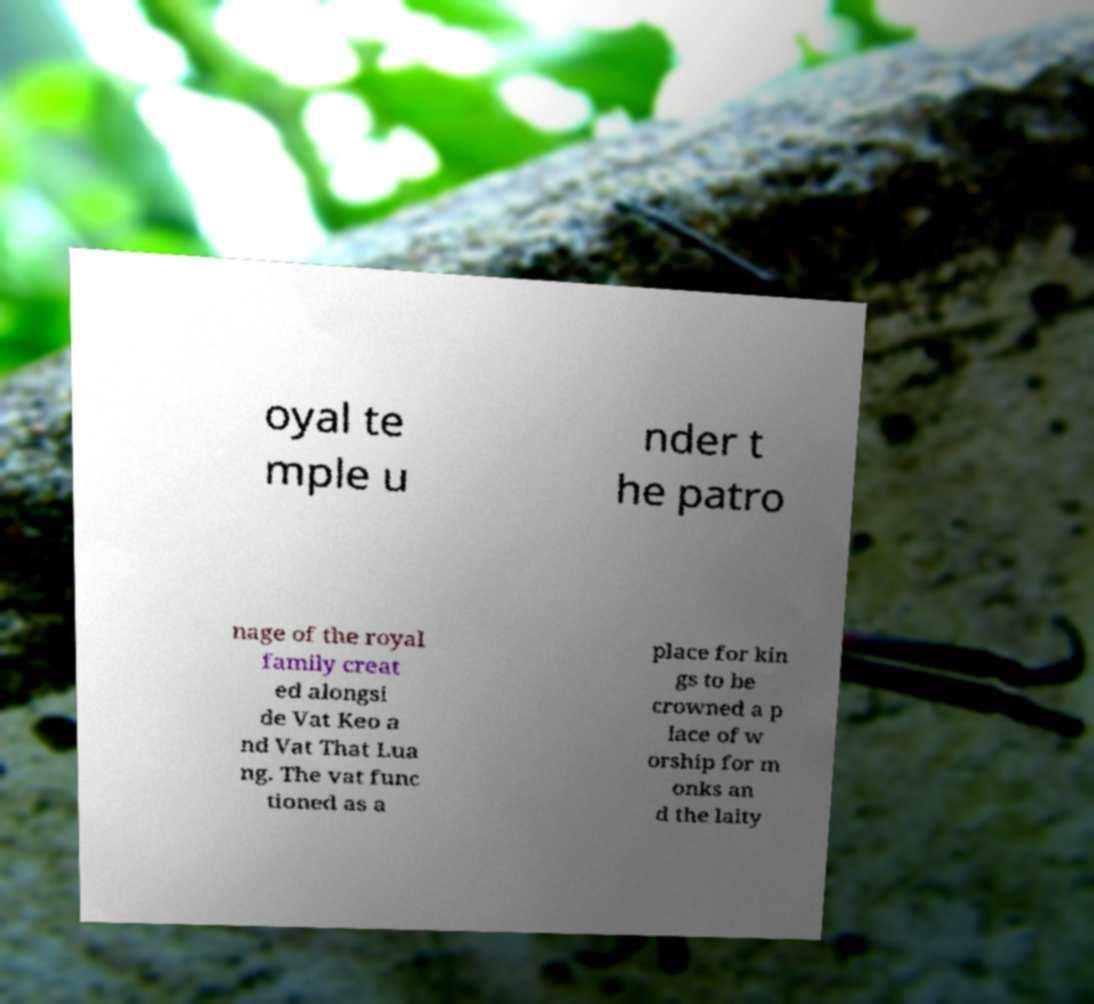What messages or text are displayed in this image? I need them in a readable, typed format. oyal te mple u nder t he patro nage of the royal family creat ed alongsi de Vat Keo a nd Vat That Lua ng. The vat func tioned as a place for kin gs to be crowned a p lace of w orship for m onks an d the laity 